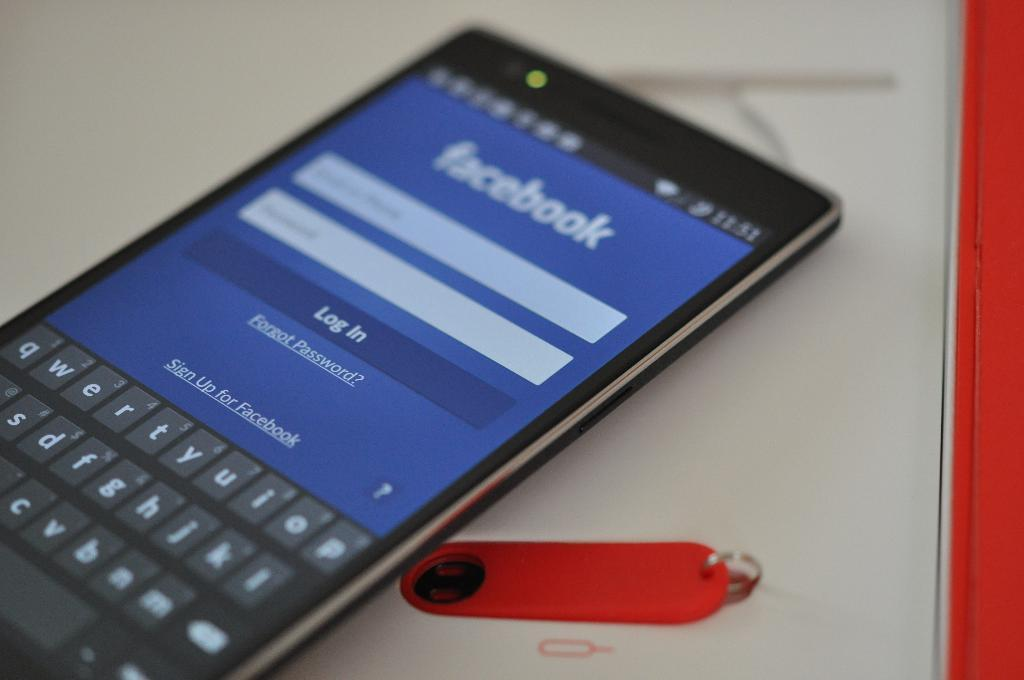<image>
Relay a brief, clear account of the picture shown. Facebook can be used on any average smart phone. 